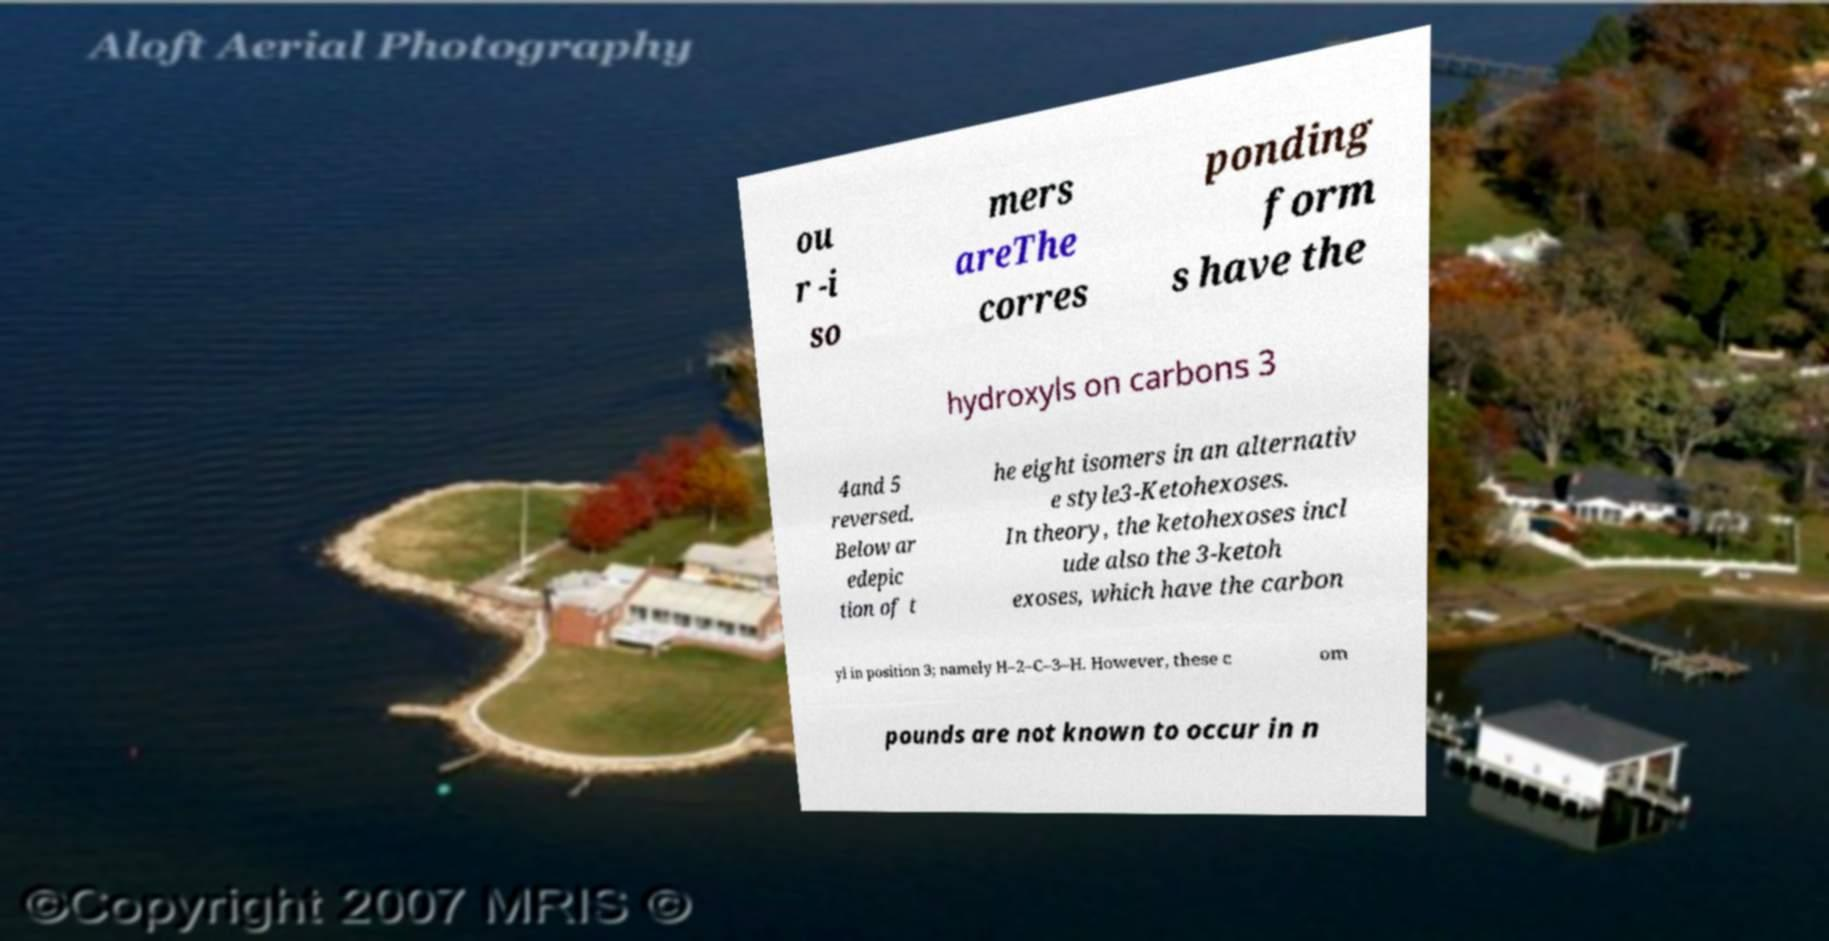What messages or text are displayed in this image? I need them in a readable, typed format. ou r -i so mers areThe corres ponding form s have the hydroxyls on carbons 3 4and 5 reversed. Below ar edepic tion of t he eight isomers in an alternativ e style3-Ketohexoses. In theory, the ketohexoses incl ude also the 3-ketoh exoses, which have the carbon yl in position 3; namely H–2–C–3–H. However, these c om pounds are not known to occur in n 